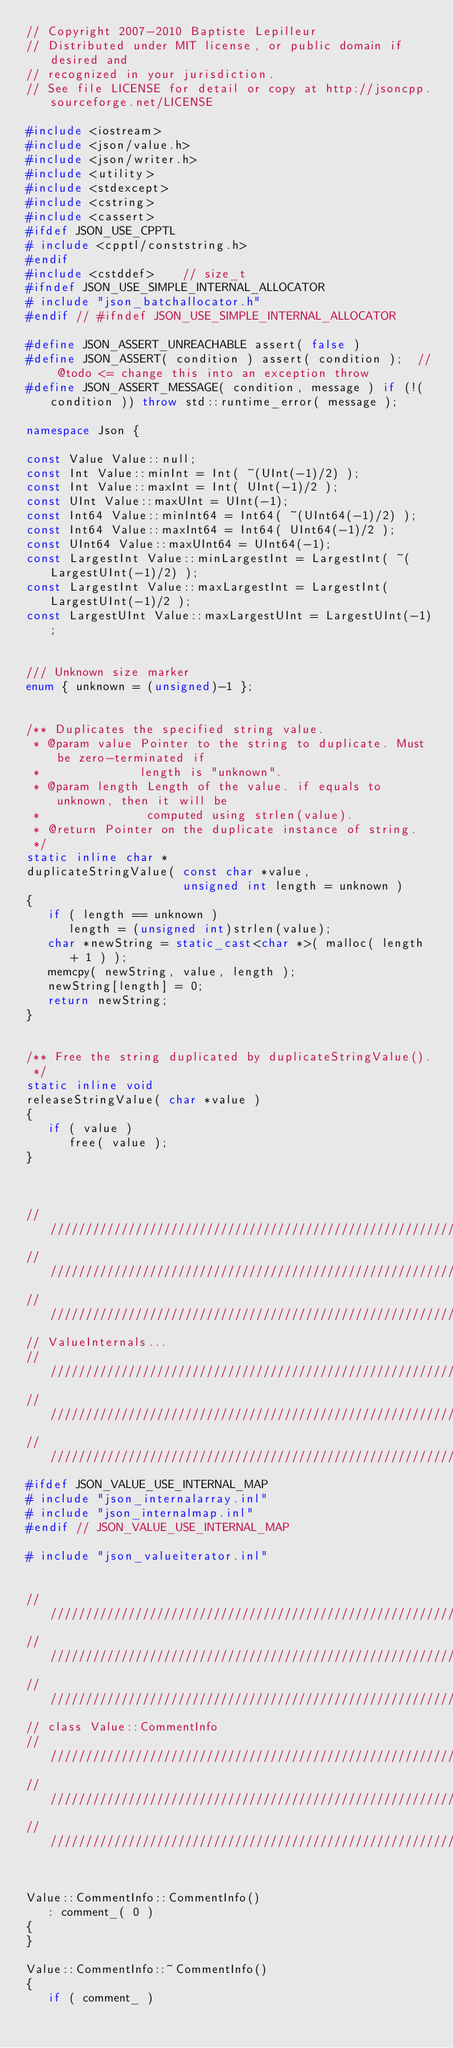Convert code to text. <code><loc_0><loc_0><loc_500><loc_500><_C++_>// Copyright 2007-2010 Baptiste Lepilleur
// Distributed under MIT license, or public domain if desired and
// recognized in your jurisdiction.
// See file LICENSE for detail or copy at http://jsoncpp.sourceforge.net/LICENSE

#include <iostream>
#include <json/value.h>
#include <json/writer.h>
#include <utility>
#include <stdexcept>
#include <cstring>
#include <cassert>
#ifdef JSON_USE_CPPTL
# include <cpptl/conststring.h>
#endif
#include <cstddef>    // size_t
#ifndef JSON_USE_SIMPLE_INTERNAL_ALLOCATOR
# include "json_batchallocator.h"
#endif // #ifndef JSON_USE_SIMPLE_INTERNAL_ALLOCATOR

#define JSON_ASSERT_UNREACHABLE assert( false )
#define JSON_ASSERT( condition ) assert( condition );  // @todo <= change this into an exception throw
#define JSON_ASSERT_MESSAGE( condition, message ) if (!( condition )) throw std::runtime_error( message );

namespace Json {

const Value Value::null;
const Int Value::minInt = Int( ~(UInt(-1)/2) );
const Int Value::maxInt = Int( UInt(-1)/2 );
const UInt Value::maxUInt = UInt(-1);
const Int64 Value::minInt64 = Int64( ~(UInt64(-1)/2) );
const Int64 Value::maxInt64 = Int64( UInt64(-1)/2 );
const UInt64 Value::maxUInt64 = UInt64(-1);
const LargestInt Value::minLargestInt = LargestInt( ~(LargestUInt(-1)/2) );
const LargestInt Value::maxLargestInt = LargestInt( LargestUInt(-1)/2 );
const LargestUInt Value::maxLargestUInt = LargestUInt(-1);


/// Unknown size marker
enum { unknown = (unsigned)-1 };


/** Duplicates the specified string value.
 * @param value Pointer to the string to duplicate. Must be zero-terminated if
 *              length is "unknown".
 * @param length Length of the value. if equals to unknown, then it will be
 *               computed using strlen(value).
 * @return Pointer on the duplicate instance of string.
 */
static inline char *
duplicateStringValue( const char *value, 
                      unsigned int length = unknown )
{
   if ( length == unknown )
      length = (unsigned int)strlen(value);
   char *newString = static_cast<char *>( malloc( length + 1 ) );
   memcpy( newString, value, length );
   newString[length] = 0;
   return newString;
}


/** Free the string duplicated by duplicateStringValue().
 */
static inline void 
releaseStringValue( char *value )
{
   if ( value )
      free( value );
}



// //////////////////////////////////////////////////////////////////
// //////////////////////////////////////////////////////////////////
// //////////////////////////////////////////////////////////////////
// ValueInternals...
// //////////////////////////////////////////////////////////////////
// //////////////////////////////////////////////////////////////////
// //////////////////////////////////////////////////////////////////
#ifdef JSON_VALUE_USE_INTERNAL_MAP
# include "json_internalarray.inl"
# include "json_internalmap.inl"
#endif // JSON_VALUE_USE_INTERNAL_MAP

# include "json_valueiterator.inl"


// //////////////////////////////////////////////////////////////////
// //////////////////////////////////////////////////////////////////
// //////////////////////////////////////////////////////////////////
// class Value::CommentInfo
// //////////////////////////////////////////////////////////////////
// //////////////////////////////////////////////////////////////////
// //////////////////////////////////////////////////////////////////


Value::CommentInfo::CommentInfo()
   : comment_( 0 )
{
}

Value::CommentInfo::~CommentInfo()
{
   if ( comment_ )</code> 